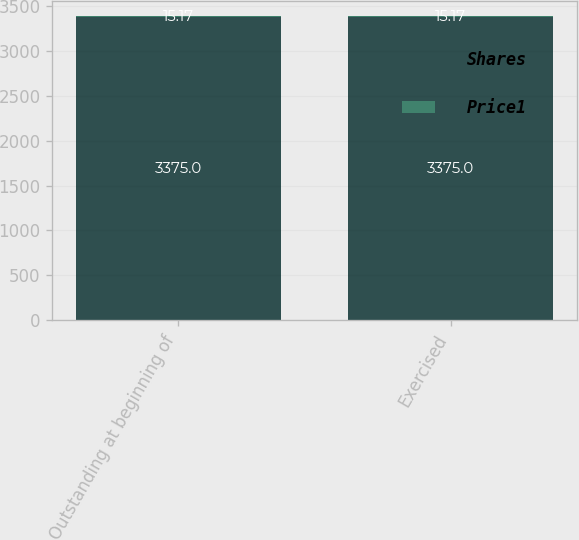Convert chart. <chart><loc_0><loc_0><loc_500><loc_500><stacked_bar_chart><ecel><fcel>Outstanding at beginning of<fcel>Exercised<nl><fcel>Shares<fcel>3375<fcel>3375<nl><fcel>Price1<fcel>15.17<fcel>15.17<nl></chart> 